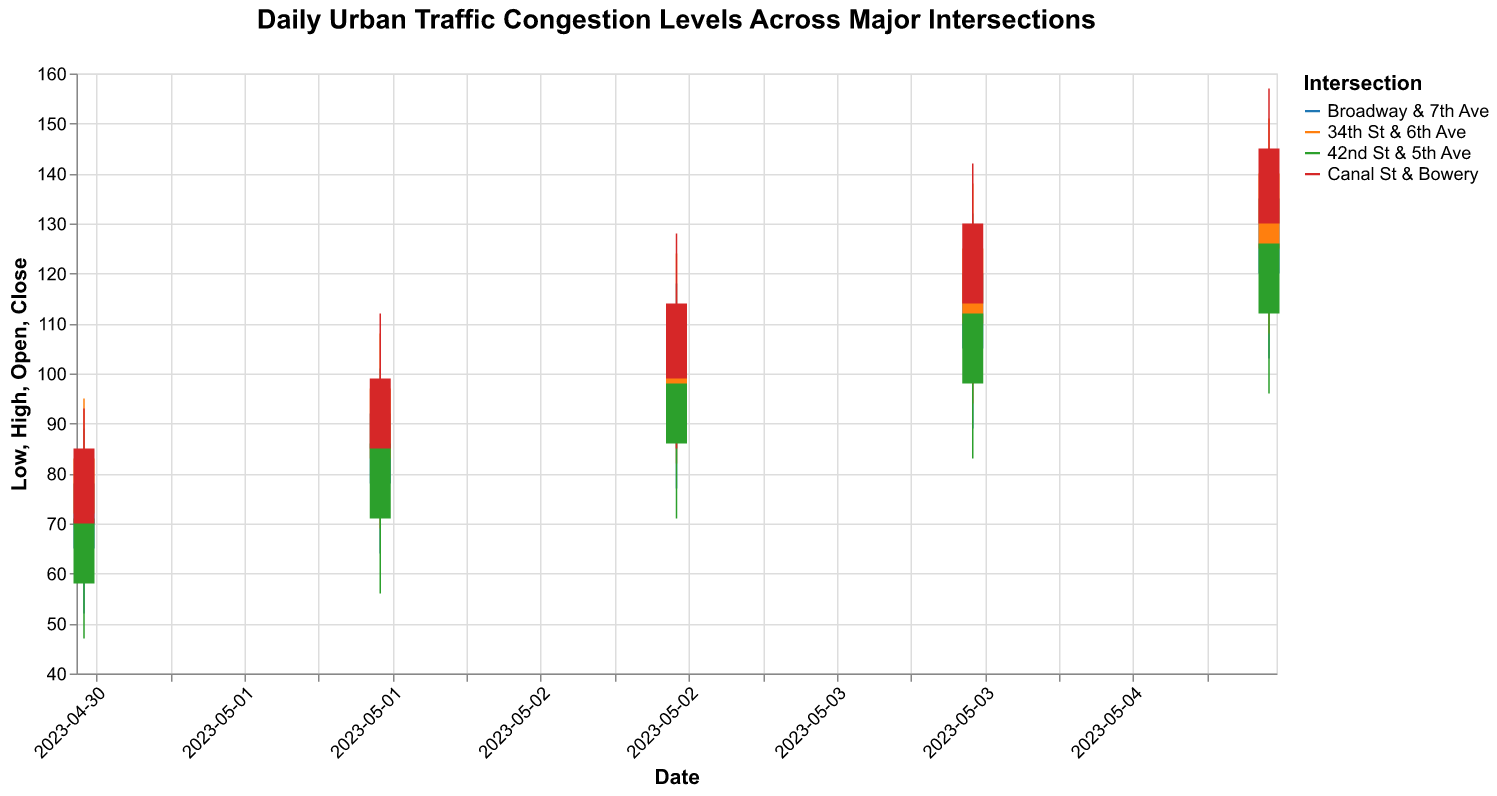How many intersections are analyzed in the chart? The chart's legend lists the intersections analyzed. Count the entries in the legend to find the number of intersections.
Answer: 4 What is the highest "High" value recorded on May 3, 2023? Locate May 3, 2023 on the x-axis and look at the "High" values for all intersections. The highest value among them is taken. On this date, the "High" values are 118, 124, 109, and 128.
Answer: 128 On which date does "Broadway & 7th Ave" have the highest "Close" value? Observe the chart and identify the "Close" values for "Broadway & 7th Ave" over different dates. The date with the maximum "Close" value is the required date. The respective "Close" values are 78, 92, 105, 120, and 135.
Answer: 2023-05-05 Which intersection had the lowest "Low" value on May 1, 2023? Identify May 1, 2023 on the x-axis and observe the "Low" values for each intersection. The lowest value among them is the answer. For this date, the "Low" values are 52, 61, 47, and 59.
Answer: 42nd St & 5th Ave What's the average "Close" value on May 4, 2023 across all intersections? Locate May 4, 2023 on the x-axis and identify the "Close" values for all intersections. Sum these values and divide by the number of intersections. The values are 120, 125, 112, and 130. Average = (120 + 125 + 112 + 130) / 4
Answer: 121.75 Compare the "Open" values for "34th St & 6th Ave" on May 2, 2023, and May 5, 2023. Is the value higher on May 5? Identify the "Open" values for "34th St & 6th Ave" on both dates. Compare to see if the value on May 5 (125) is higher than that on May 2 (83).
Answer: Yes What is the difference between the "High" and "Low" values for "Canal St & Bowery" on May 3, 2023? Observe the "High" and "Low" values for "Canal St & Bowery" on May 3, 2023. The difference is 128 - 85.
Answer: 43 Which intersection had the highest fluctuation (difference between High and Low) on May 2, 2023? On May 2, 2023, calculate the difference between "High" and "Low" values for each intersection: (101-64), (108-69), (94-56), and (112-73). The highest difference is for intersection Canal St & Bowery (112-73=39).
Answer: Canal St & Bowery What pattern do you observe in the "Close" values of "42nd St & 5th Ave" from May 1 to May 5? Look at the "Close" values of "42nd St & 5th Ave" across the dates. The values are: May 1 (71), May 2 (86), May 3 (98), May 4 (112), and May 5 (126). The pattern shows a steadily increasing trend.
Answer: Increasing trend 